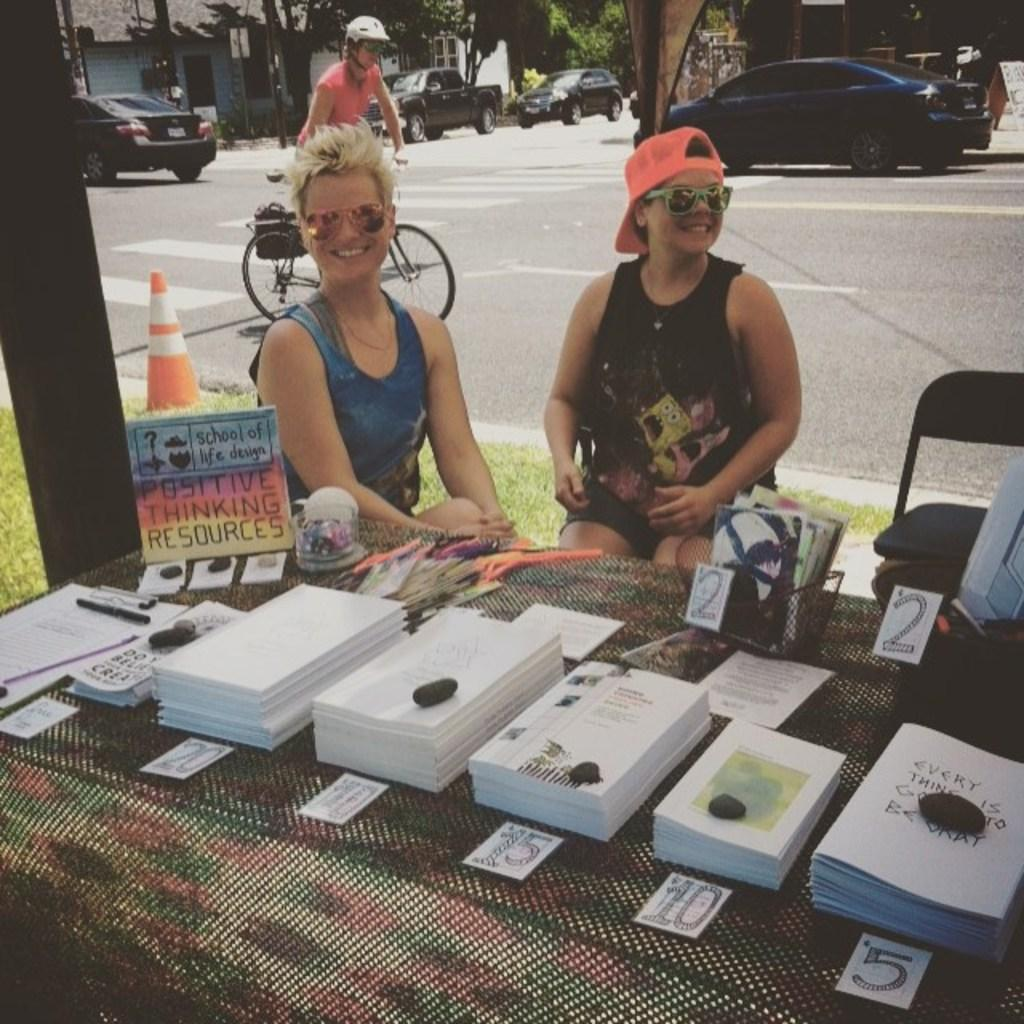How many women are in the image? There are two women in the image. What are the women doing in the image? The women are sitting on chairs. What can be seen in the background of the image? There is a road visible in the image, with cars on it. What type of vegetation is present in the image? There are trees in the image. What type of sheet is covering the women's necks and toes in the image? There is no sheet present in the image, and the women's necks and toes are not covered. 